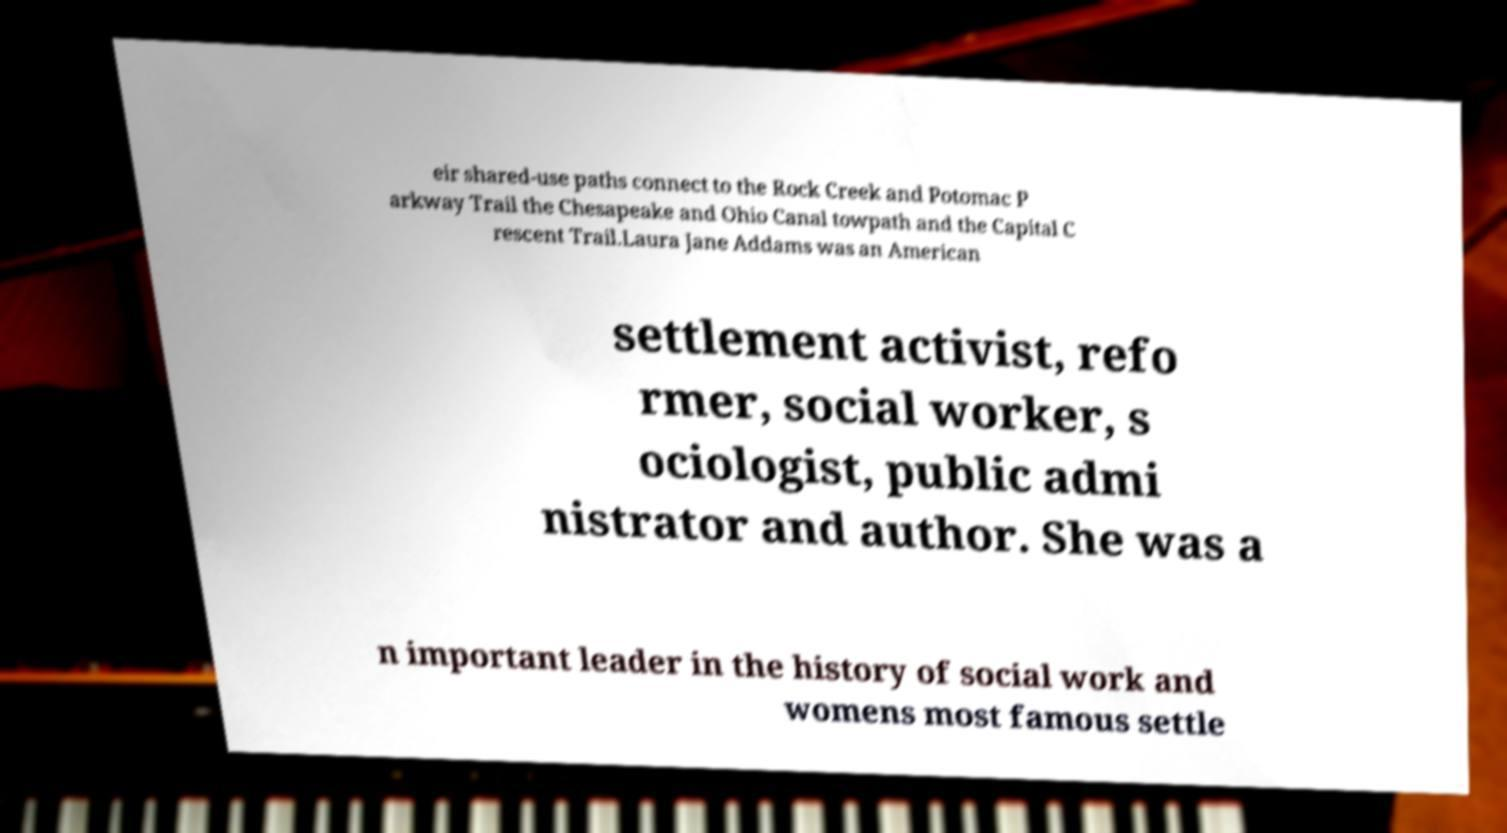Please read and relay the text visible in this image. What does it say? eir shared-use paths connect to the Rock Creek and Potomac P arkway Trail the Chesapeake and Ohio Canal towpath and the Capital C rescent Trail.Laura Jane Addams was an American settlement activist, refo rmer, social worker, s ociologist, public admi nistrator and author. She was a n important leader in the history of social work and womens most famous settle 